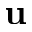<formula> <loc_0><loc_0><loc_500><loc_500>u</formula> 